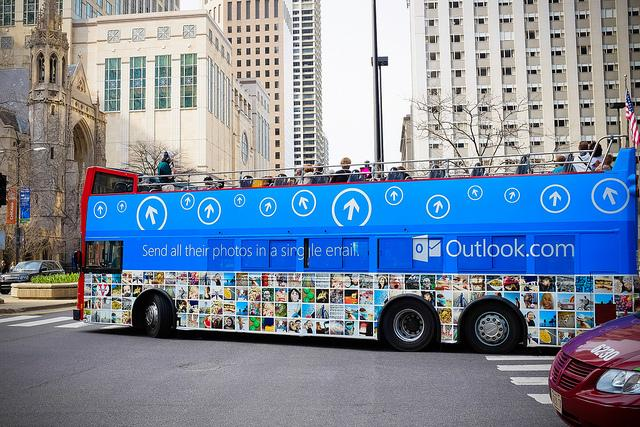What country is this street found in? united states 